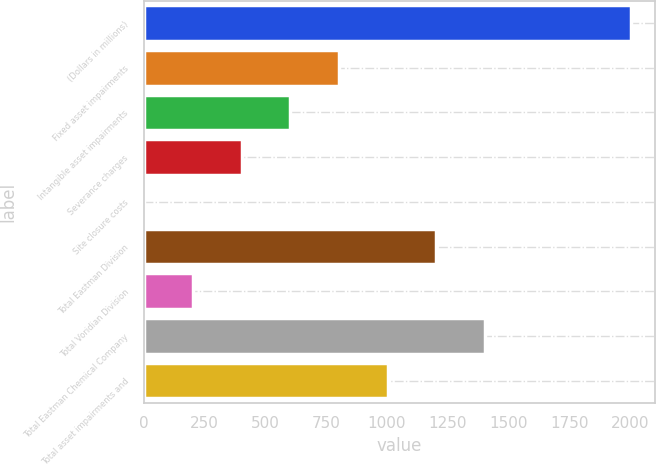Convert chart to OTSL. <chart><loc_0><loc_0><loc_500><loc_500><bar_chart><fcel>(Dollars in millions)<fcel>Fixed asset impairments<fcel>Intangible asset impairments<fcel>Severance charges<fcel>Site closure costs<fcel>Total Eastman Division<fcel>Total Voridian Division<fcel>Total Eastman Chemical Company<fcel>Total asset impairments and<nl><fcel>2003<fcel>803<fcel>603<fcel>403<fcel>3<fcel>1203<fcel>203<fcel>1403<fcel>1003<nl></chart> 